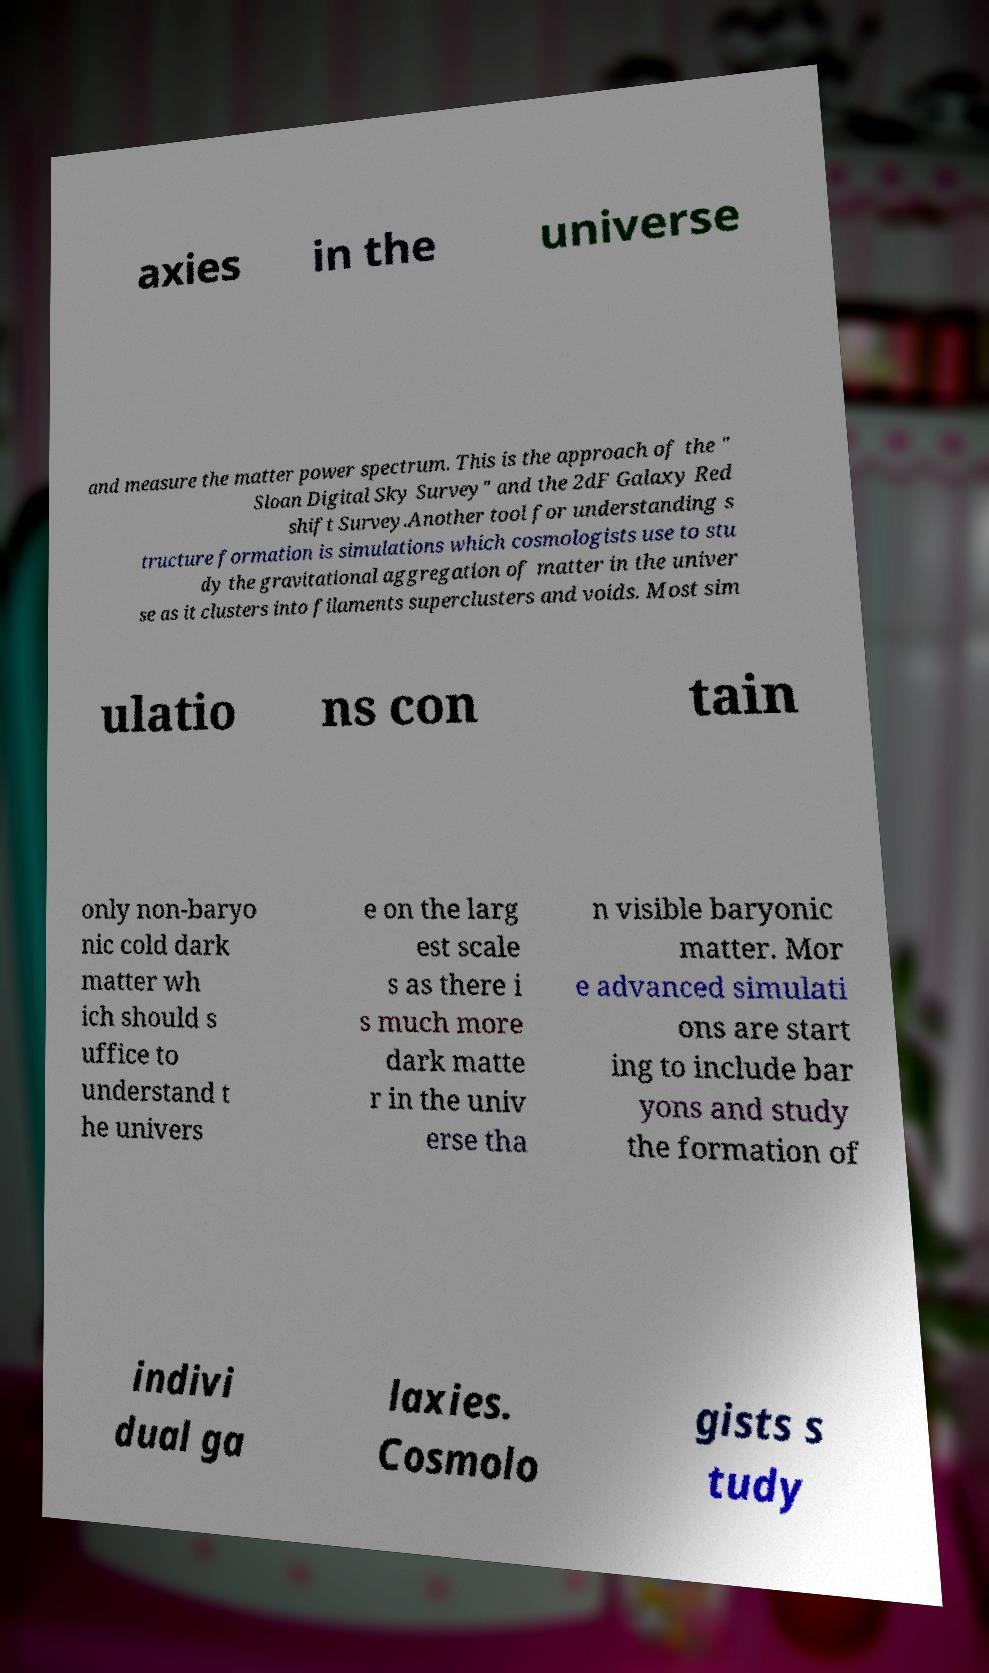What messages or text are displayed in this image? I need them in a readable, typed format. axies in the universe and measure the matter power spectrum. This is the approach of the " Sloan Digital Sky Survey" and the 2dF Galaxy Red shift Survey.Another tool for understanding s tructure formation is simulations which cosmologists use to stu dy the gravitational aggregation of matter in the univer se as it clusters into filaments superclusters and voids. Most sim ulatio ns con tain only non-baryo nic cold dark matter wh ich should s uffice to understand t he univers e on the larg est scale s as there i s much more dark matte r in the univ erse tha n visible baryonic matter. Mor e advanced simulati ons are start ing to include bar yons and study the formation of indivi dual ga laxies. Cosmolo gists s tudy 